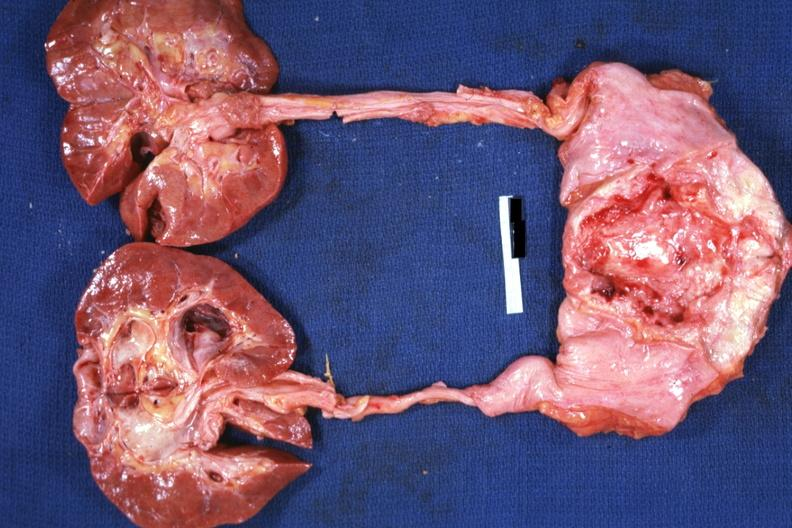does this image show view of prostate bladder ureters and kidneys quite good shows prostate tumor invading floor of bladder causing hydroureter and hydronephrosis?
Answer the question using a single word or phrase. Yes 